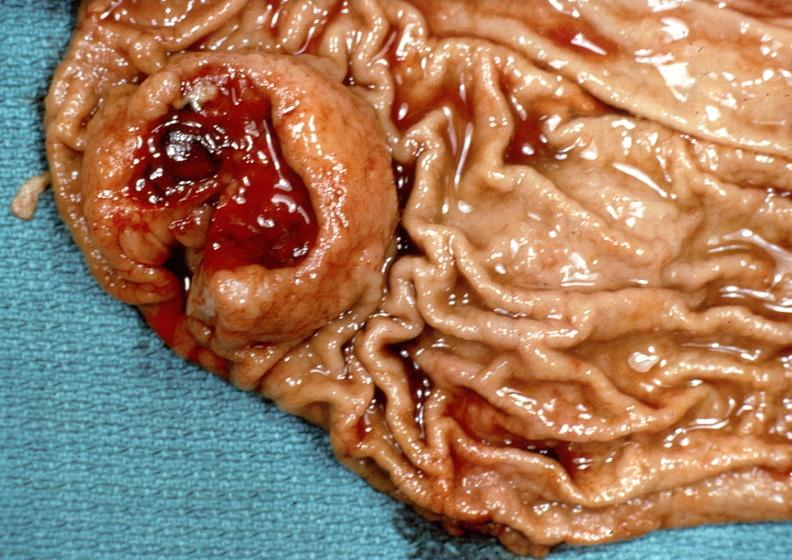what does this image show?
Answer the question using a single word or phrase. Stomach 